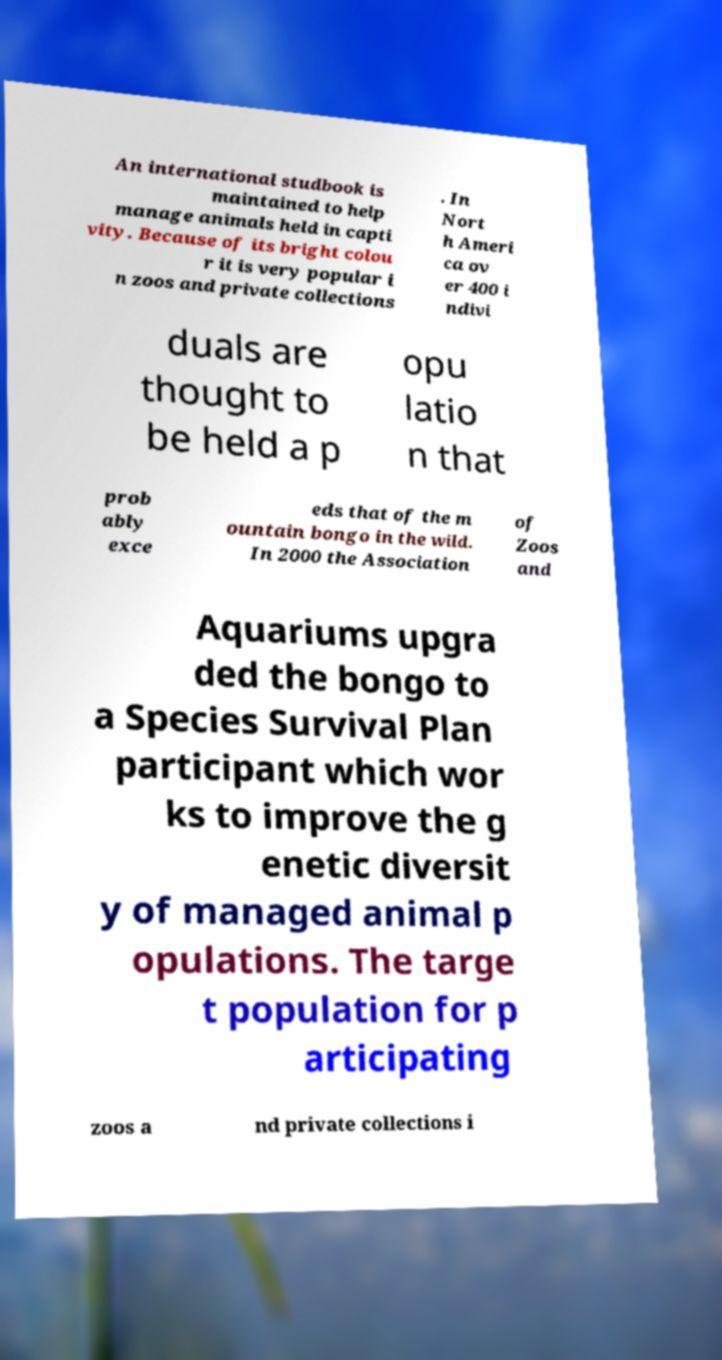There's text embedded in this image that I need extracted. Can you transcribe it verbatim? An international studbook is maintained to help manage animals held in capti vity. Because of its bright colou r it is very popular i n zoos and private collections . In Nort h Ameri ca ov er 400 i ndivi duals are thought to be held a p opu latio n that prob ably exce eds that of the m ountain bongo in the wild. In 2000 the Association of Zoos and Aquariums upgra ded the bongo to a Species Survival Plan participant which wor ks to improve the g enetic diversit y of managed animal p opulations. The targe t population for p articipating zoos a nd private collections i 